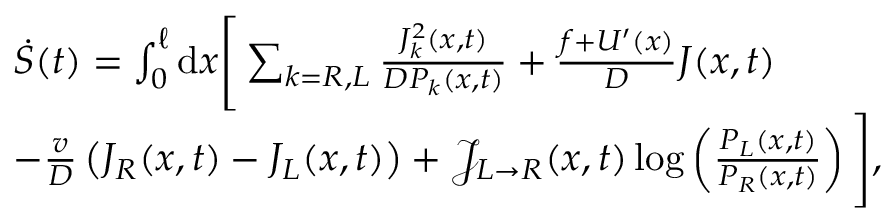Convert formula to latex. <formula><loc_0><loc_0><loc_500><loc_500>\begin{array} { r l } & { \dot { S } ( t ) = \int _ { 0 } ^ { \ell } d x \left [ \sum _ { k = R , L } \frac { J _ { k } ^ { 2 } ( x , t ) } { D P _ { k } ( x , t ) } + \frac { f + U ^ { \prime } ( x ) } { D } J ( x , t ) } \\ & { - \frac { v } { D } \left ( J _ { R } ( x , t ) - J _ { L } ( x , t ) \right ) + \mathcal { J } _ { L \rightarrow R } ( x , t ) \log \left ( \frac { P _ { L } ( x , t ) } { P _ { R } ( x , t ) } \right ) \right ] , } \end{array}</formula> 